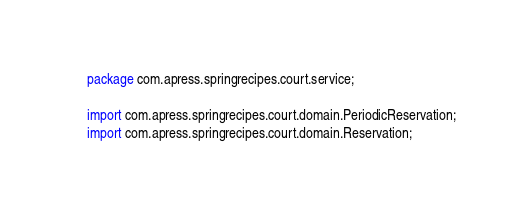<code> <loc_0><loc_0><loc_500><loc_500><_Java_>package com.apress.springrecipes.court.service;

import com.apress.springrecipes.court.domain.PeriodicReservation;
import com.apress.springrecipes.court.domain.Reservation;</code> 